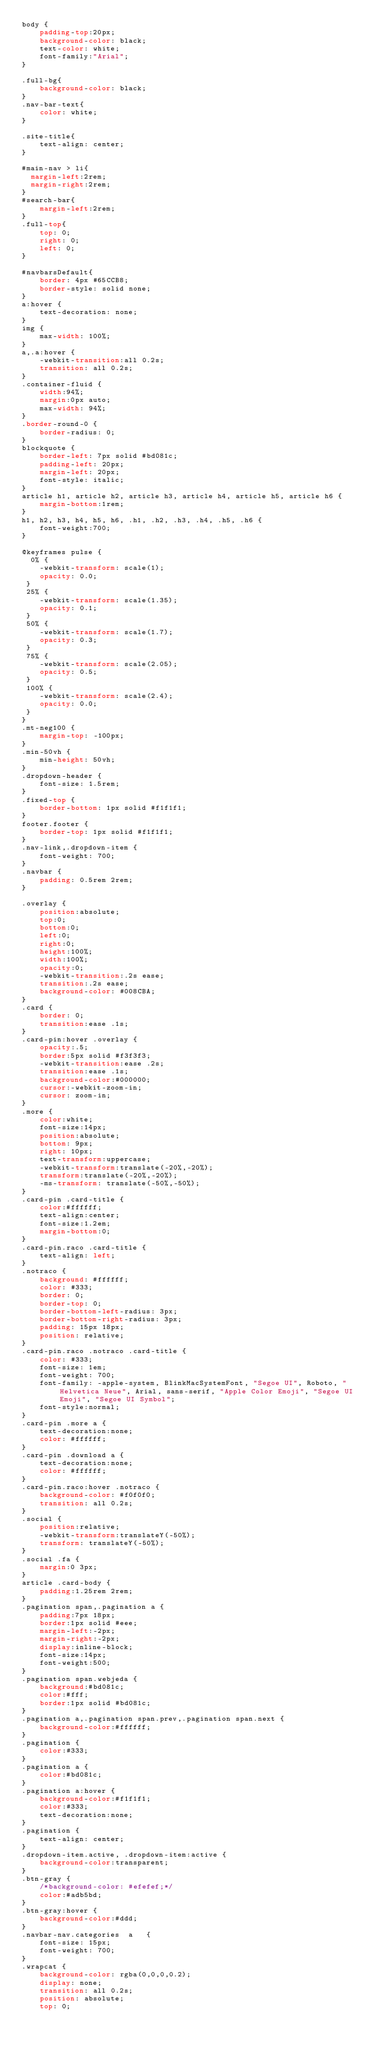<code> <loc_0><loc_0><loc_500><loc_500><_CSS_>body {
	padding-top:20px;
    background-color: black;
    text-color: white;
    font-family:"Arial";
}

.full-bg{
    background-color: black;
}
.nav-bar-text{
    color: white;
}

.site-title{
    text-align: center;
}

#main-nav > li{
  margin-left:2rem;
  margin-right:2rem;
}
#search-bar{
    margin-left:2rem;
}
.full-top{
    top: 0;
    right: 0;
    left: 0;
}

#navbarsDefault{
    border: 4px #65CCB8;
    border-style: solid none;
}
a:hover {
	text-decoration: none;
}
img {
	max-width: 100%;
}
a,.a:hover {
	-webkit-transition:all 0.2s;
	transition: all 0.2s;
}
.container-fluid {
	width:94%;
	margin:0px auto;
	max-width: 94%;
}
.border-round-0 {
	border-radius: 0;
}
blockquote {
    border-left: 7px solid #bd081c;
    padding-left: 20px;
    margin-left: 20px;
    font-style: italic;
}
article h1, article h2, article h3, article h4, article h5, article h6 {
    margin-bottom:1rem;
}
h1, h2, h3, h4, h5, h6, .h1, .h2, .h3, .h4, .h5, .h6 {
    font-weight:700;
}

@keyframes pulse {
  0% {
    -webkit-transform: scale(1);
    opacity: 0.0;
 }
 25% {
    -webkit-transform: scale(1.35);
    opacity: 0.1;
 }
 50% {
    -webkit-transform: scale(1.7);
    opacity: 0.3;
 }
 75% {
    -webkit-transform: scale(2.05);
    opacity: 0.5;
 }
 100% {
    -webkit-transform: scale(2.4);
    opacity: 0.0;
 }
}
.mt-neg100 {
	margin-top: -100px;
}
.min-50vh {
	min-height: 50vh;
}
.dropdown-header {
	font-size: 1.5rem;
}
.fixed-top {
	border-bottom: 1px solid #f1f1f1;
}
footer.footer {
	border-top: 1px solid #f1f1f1;
}
.nav-link,.dropdown-item {
	font-weight: 700;
}
.navbar {
	padding: 0.5rem 2rem;
}

.overlay {
	position:absolute;
	top:0;
	bottom:0;
	left:0;
	right:0;
	height:100%;
	width:100%;
	opacity:0;
	-webkit-transition:.2s ease;
	transition:.2s ease;
	background-color: #008CBA;
}
.card {
	border: 0;
    transition:ease .1s;
}
.card-pin:hover .overlay {
	opacity:.5;
	border:5px solid #f3f3f3;
	-webkit-transition:ease .2s;
	transition:ease .1s;
	background-color:#000000;
	cursor:-webkit-zoom-in;
	cursor: zoom-in;
}
.more {
	color:white;
	font-size:14px;
	position:absolute;
	bottom: 9px;
    right: 10px;
	text-transform:uppercase;
	-webkit-transform:translate(-20%,-20%);
	transform:translate(-20%,-20%);
	-ms-transform: translate(-50%,-50%);
}
.card-pin .card-title {
	color:#ffffff;
	text-align:center;
	font-size:1.2em;
    margin-bottom:0;
}
.card-pin.raco .card-title {
    text-align: left;
}
.notraco {
    background: #ffffff;
    color: #333;
    border: 0;
    border-top: 0;
    border-bottom-left-radius: 3px;
    border-bottom-right-radius: 3px;
    padding: 15px 18px;
    position: relative;
}
.card-pin.raco .notraco .card-title {
    color: #333;
    font-size: 1em;
    font-weight: 700;
    font-family: -apple-system, BlinkMacSystemFont, "Segoe UI", Roboto, "Helvetica Neue", Arial, sans-serif, "Apple Color Emoji", "Segoe UI Emoji", "Segoe UI Symbol";
    font-style:normal;
}
.card-pin .more a {
	text-decoration:none;
	color: #ffffff;
}
.card-pin .download a {
	text-decoration:none;
	color: #ffffff;
}
.card-pin.raco:hover .notraco {
    background-color: #f0f0f0;
    transition: all 0.2s;
}
.social {
	position:relative;
	-webkit-transform:translateY(-50%);
	transform: translateY(-50%);
}
.social .fa {
	margin:0 3px;
}
article .card-body {
	padding:1.25rem 2rem;
}
.pagination span,.pagination a {
	padding:7px 18px;
	border:1px solid #eee;
	margin-left:-2px;
	margin-right:-2px;
	display:inline-block;
	font-size:14px;
	font-weight:500;
}
.pagination span.webjeda {
	background:#bd081c;
	color:#fff;
	border:1px solid #bd081c;
}
.pagination a,.pagination span.prev,.pagination span.next {
	background-color:#ffffff;
}
.pagination {
	color:#333;
}
.pagination a {
	color:#bd081c;
}
.pagination a:hover {
	background-color:#f1f1f1;
	color:#333;
	text-decoration:none;
}
.pagination {
	text-align: center;
}
.dropdown-item.active, .dropdown-item:active {
    background-color:transparent;
}
.btn-gray {
    /*background-color: #efefef;*/
    color:#adb5bd;
}
.btn-gray:hover {
    background-color:#ddd;
}
.navbar-nav.categories  a   {
    font-size: 15px;
    font-weight: 700;
}
.wrapcat {
    background-color: rgba(0,0,0,0.2);
    display: none;
    transition: all 0.2s;
    position: absolute;
    top: 0;</code> 